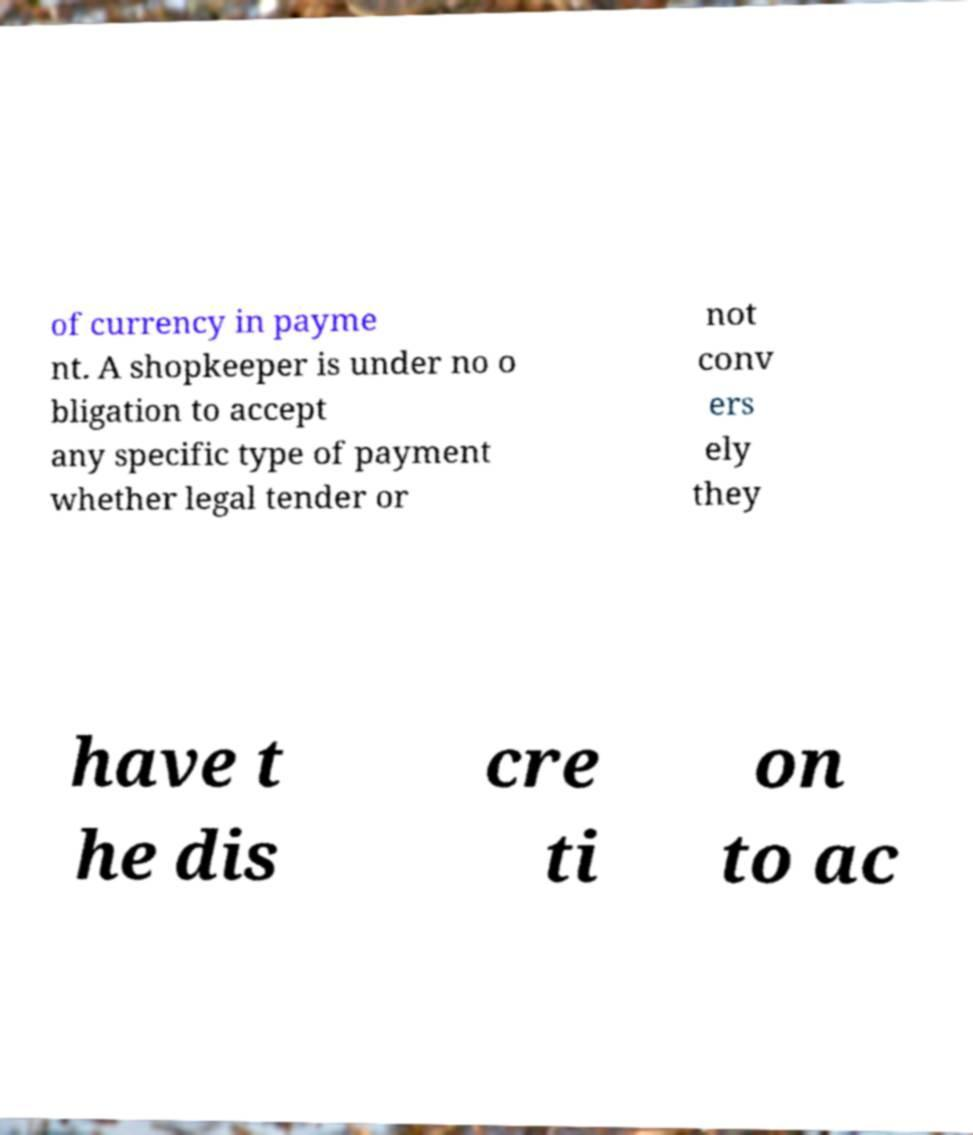Please identify and transcribe the text found in this image. of currency in payme nt. A shopkeeper is under no o bligation to accept any specific type of payment whether legal tender or not conv ers ely they have t he dis cre ti on to ac 